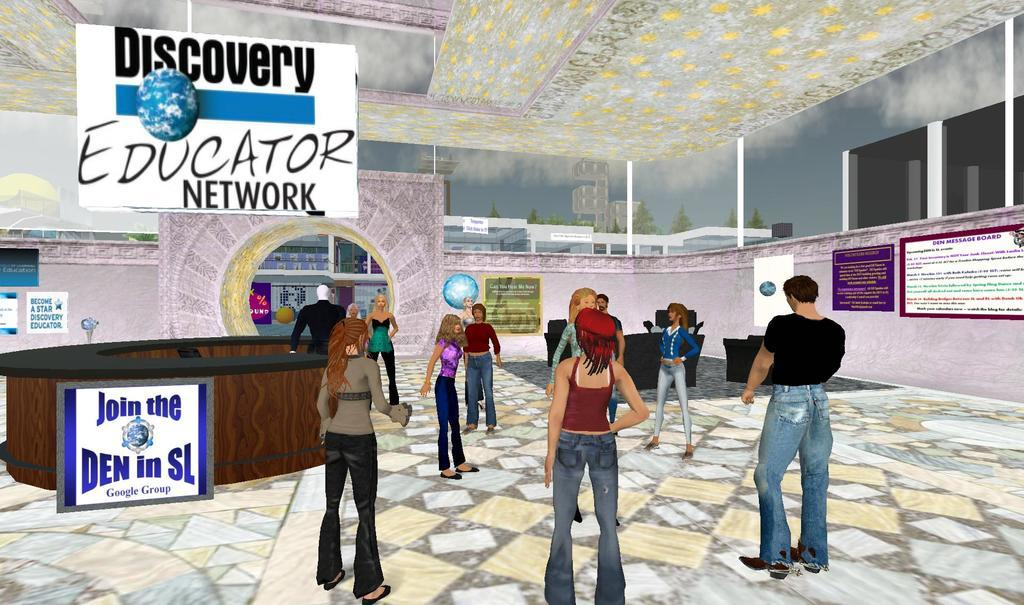What type of characters are present in the image? There are animated persons visible in the image. What is located in the middle of the image? There is a hoarding board in the middle of the image. What piece of furniture can be seen in the image? There is a table in the image. What architectural feature is present in the image? There is a wall in the image. What can be used for ventilation or viewing the outside in the image? There is a window in the image. What type of head ornament is worn by the animated persons in the image? There is no head ornament visible on the animated persons in the image. What class of objects are the animated persons attending in the image? There is no indication of a class or educational setting in the image. 